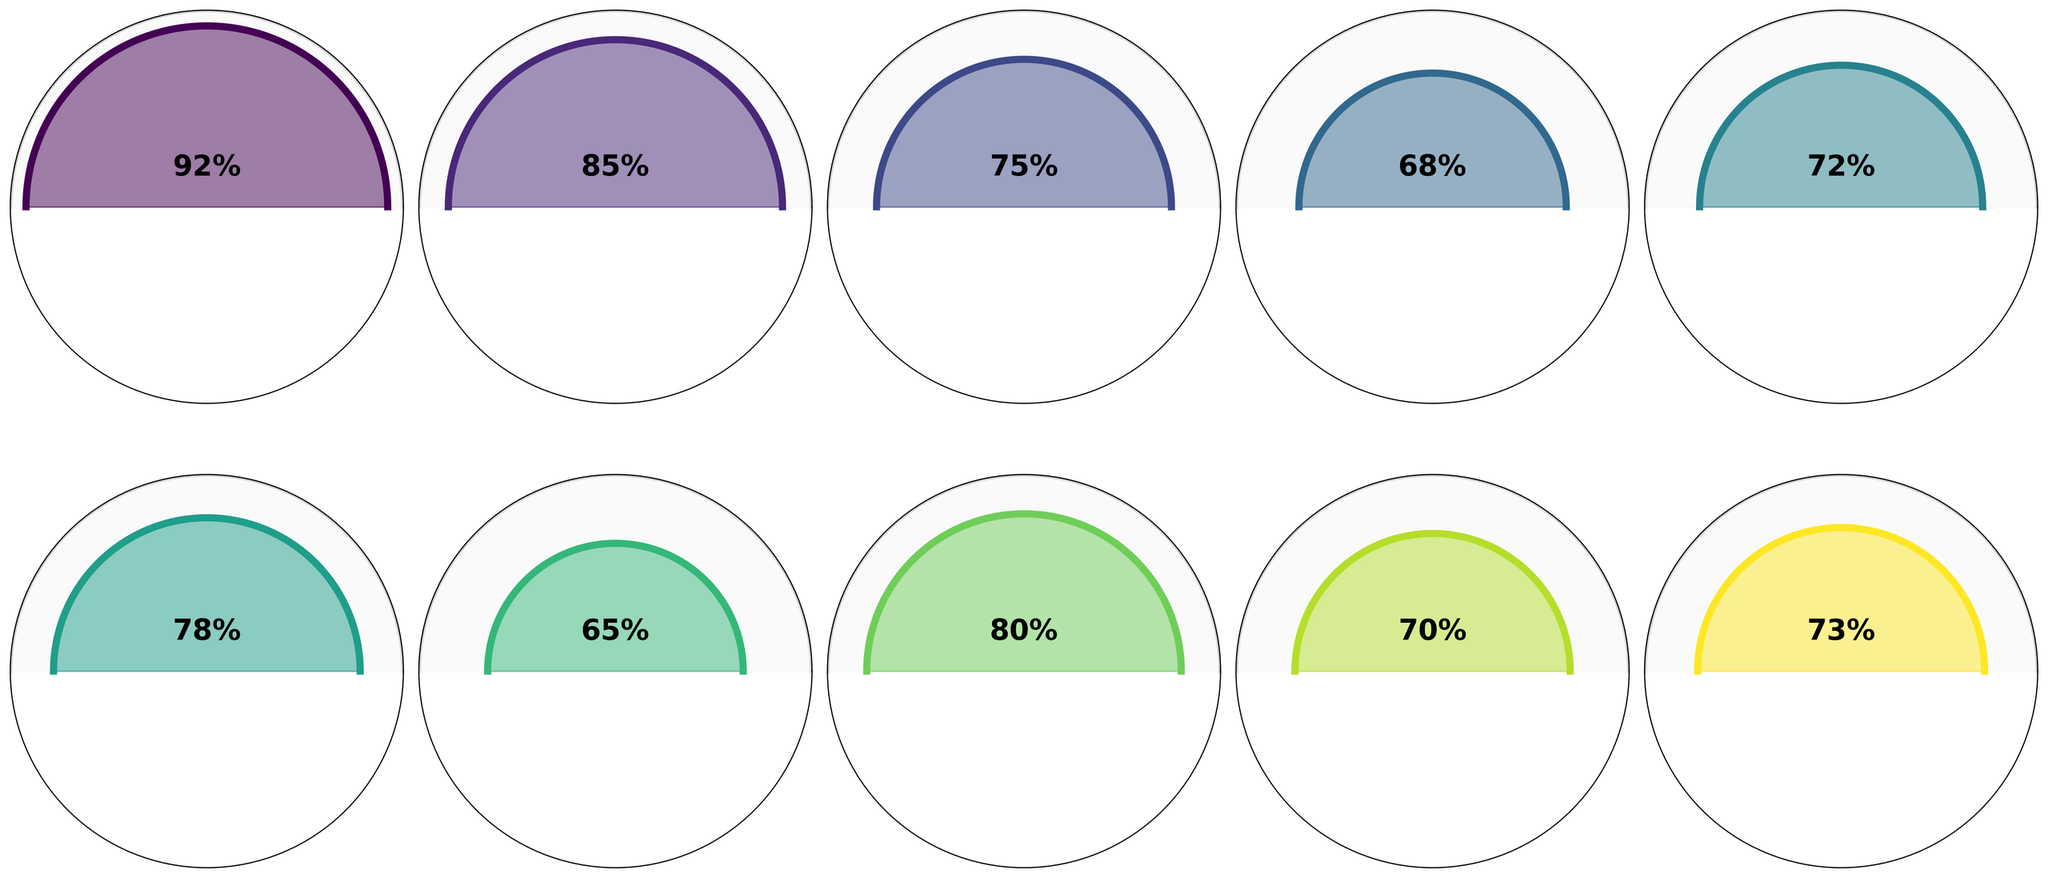What's the highest success rate among the techniques shown? The highest success rate can be identified by comparing the percentages. DNA Analysis has the highest rate at 92%.
Answer: 92% Which two techniques have a success rate above 80% but below 90%? By examining the percentages, Fingerprint Identification at 85% and Gunshot Residue Analysis at 80% fall within this range.
Answer: Fingerprint Identification and Gunshot Residue Analysis What's the combined success rate of Fiber Analysis and Hair Analysis? Adding the success rates of Fiber Analysis (75%) and Hair Analysis (68%) gives a combined value of 75 + 68 = 143%.
Answer: 143% Which technique has a lower success rate: Soil Analysis or Shoe Print Analysis? Comparing the percentages, Soil Analysis has a 65% success rate and Shoe Print Analysis has a 70% success rate; thus, Soil Analysis is lower.
Answer: Soil Analysis How many techniques have a success rate below 75%? By counting the techniques with success rates below 75%, we find Hair Analysis (68%), Paint Chip Analysis (72%), Soil Analysis (65%), Shoe Print Analysis (70%), and Tool Mark Analysis (73%), which totals 5 techniques.
Answer: 5 What's the difference in success rate between Paint Chip Analysis and Glass Fragment Analysis? Subtracting the success rate of Paint Chip Analysis (72%) from Glass Fragment Analysis (78%) gives a difference of 78 - 72 = 6%.
Answer: 6% Among the analyzed techniques, which one is closest to a 50% success rate? By looking at all the success rates, none are close to 50%; hence, no techniques are nearest to 50%.
Answer: None What is the average success rate of all the techniques? Adding all the success rates (92 + 85 + 75 + 68 + 72 + 78 + 65 + 80 + 70 + 73) gives 758%, and dividing by the number of techniques (10) gives an average of 75.8%.
Answer: 75.8% Which technique has a higher success rate, Tool Mark Analysis or Fiber Analysis? Comparing the percentages, Fiber Analysis has a 75% success rate and Tool Mark Analysis has a 73% success rate, making Fiber Analysis higher.
Answer: Fiber Analysis 